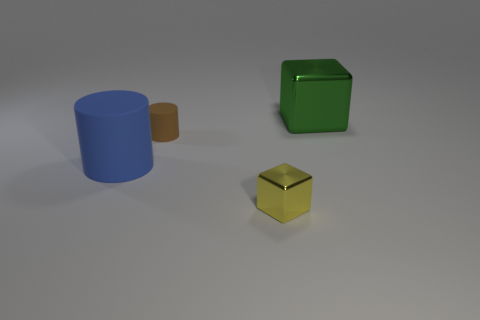Add 2 green objects. How many objects exist? 6 Subtract all tiny cyan rubber things. Subtract all large blue rubber objects. How many objects are left? 3 Add 4 small yellow metal things. How many small yellow metal things are left? 5 Add 2 brown cylinders. How many brown cylinders exist? 3 Subtract 0 yellow balls. How many objects are left? 4 